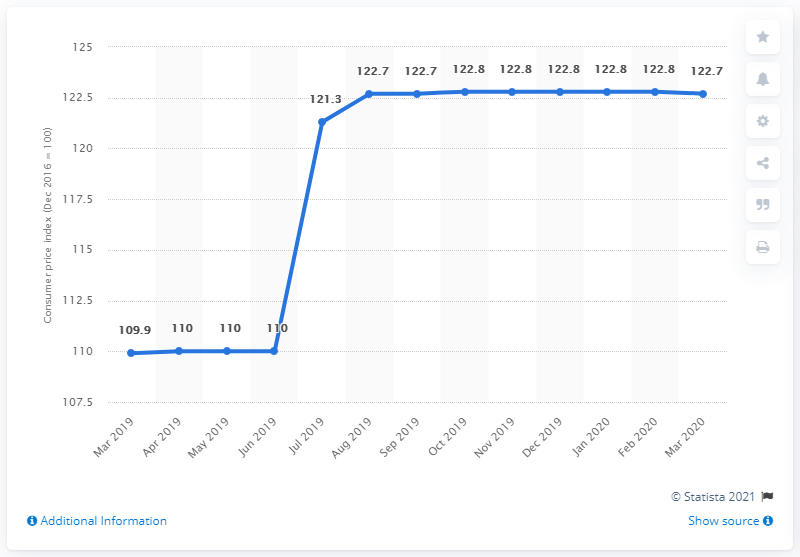Point out several critical features in this image. Of the months that have 110, 3 have it. The month of July 2019 experienced a significant increase in the Consumer Price Index (CPI) compared to previous months. 